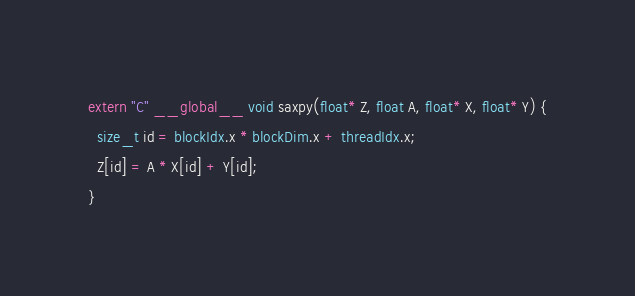Convert code to text. <code><loc_0><loc_0><loc_500><loc_500><_Cuda_>extern "C" __global__ void saxpy(float* Z, float A, float* X, float* Y) {
  size_t id = blockIdx.x * blockDim.x + threadIdx.x;
  Z[id] = A * X[id] + Y[id];
}

</code> 